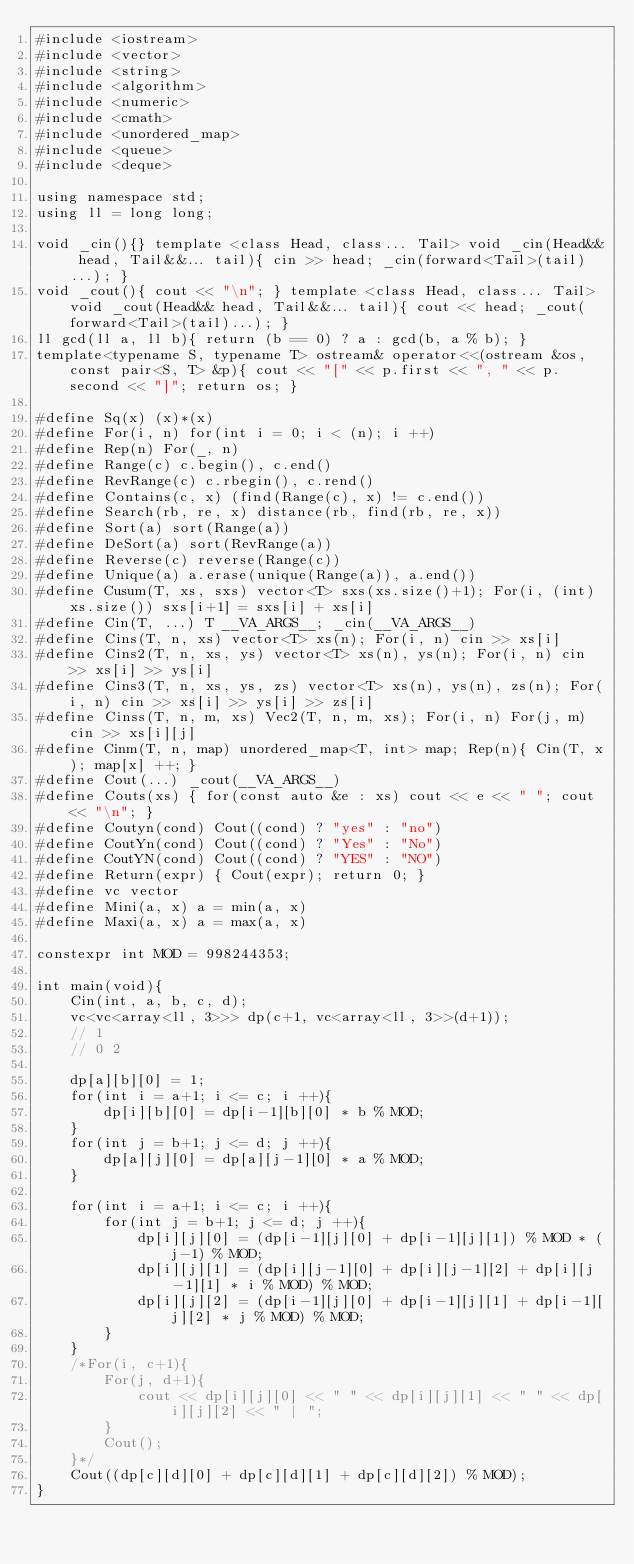Convert code to text. <code><loc_0><loc_0><loc_500><loc_500><_C++_>#include <iostream>
#include <vector>
#include <string>
#include <algorithm>
#include <numeric>
#include <cmath>
#include <unordered_map>
#include <queue>
#include <deque>

using namespace std;
using ll = long long;

void _cin(){} template <class Head, class... Tail> void _cin(Head&& head, Tail&&... tail){ cin >> head; _cin(forward<Tail>(tail)...); }
void _cout(){ cout << "\n"; } template <class Head, class... Tail> void _cout(Head&& head, Tail&&... tail){ cout << head; _cout(forward<Tail>(tail)...); }
ll gcd(ll a, ll b){ return (b == 0) ? a : gcd(b, a % b); }
template<typename S, typename T> ostream& operator<<(ostream &os, const pair<S, T> &p){ cout << "[" << p.first << ", " << p.second << "]"; return os; }

#define Sq(x) (x)*(x)
#define For(i, n) for(int i = 0; i < (n); i ++)
#define Rep(n) For(_, n)
#define Range(c) c.begin(), c.end()
#define RevRange(c) c.rbegin(), c.rend()
#define Contains(c, x) (find(Range(c), x) != c.end())
#define Search(rb, re, x) distance(rb, find(rb, re, x))
#define Sort(a) sort(Range(a))
#define DeSort(a) sort(RevRange(a))
#define Reverse(c) reverse(Range(c))
#define Unique(a) a.erase(unique(Range(a)), a.end())
#define Cusum(T, xs, sxs) vector<T> sxs(xs.size()+1); For(i, (int)xs.size()) sxs[i+1] = sxs[i] + xs[i]
#define Cin(T, ...) T __VA_ARGS__; _cin(__VA_ARGS__)
#define Cins(T, n, xs) vector<T> xs(n); For(i, n) cin >> xs[i]
#define Cins2(T, n, xs, ys) vector<T> xs(n), ys(n); For(i, n) cin >> xs[i] >> ys[i]
#define Cins3(T, n, xs, ys, zs) vector<T> xs(n), ys(n), zs(n); For(i, n) cin >> xs[i] >> ys[i] >> zs[i]
#define Cinss(T, n, m, xs) Vec2(T, n, m, xs); For(i, n) For(j, m) cin >> xs[i][j]
#define Cinm(T, n, map) unordered_map<T, int> map; Rep(n){ Cin(T, x); map[x] ++; }
#define Cout(...) _cout(__VA_ARGS__)
#define Couts(xs) { for(const auto &e : xs) cout << e << " "; cout << "\n"; }
#define Coutyn(cond) Cout((cond) ? "yes" : "no")
#define CoutYn(cond) Cout((cond) ? "Yes" : "No")
#define CoutYN(cond) Cout((cond) ? "YES" : "NO")
#define Return(expr) { Cout(expr); return 0; }
#define vc vector
#define Mini(a, x) a = min(a, x)
#define Maxi(a, x) a = max(a, x)

constexpr int MOD = 998244353;

int main(void){
    Cin(int, a, b, c, d);
    vc<vc<array<ll, 3>>> dp(c+1, vc<array<ll, 3>>(d+1));
    // 1
    // 0 2
    
    dp[a][b][0] = 1;
    for(int i = a+1; i <= c; i ++){
        dp[i][b][0] = dp[i-1][b][0] * b % MOD;
    }
    for(int j = b+1; j <= d; j ++){
        dp[a][j][0] = dp[a][j-1][0] * a % MOD;
    }
    
    for(int i = a+1; i <= c; i ++){
        for(int j = b+1; j <= d; j ++){
            dp[i][j][0] = (dp[i-1][j][0] + dp[i-1][j][1]) % MOD * (j-1) % MOD;
            dp[i][j][1] = (dp[i][j-1][0] + dp[i][j-1][2] + dp[i][j-1][1] * i % MOD) % MOD;
            dp[i][j][2] = (dp[i-1][j][0] + dp[i-1][j][1] + dp[i-1][j][2] * j % MOD) % MOD;
        }
    }
    /*For(i, c+1){
        For(j, d+1){
            cout << dp[i][j][0] << " " << dp[i][j][1] << " " << dp[i][j][2] << " | ";
        }
        Cout();
    }*/
    Cout((dp[c][d][0] + dp[c][d][1] + dp[c][d][2]) % MOD);
}
</code> 